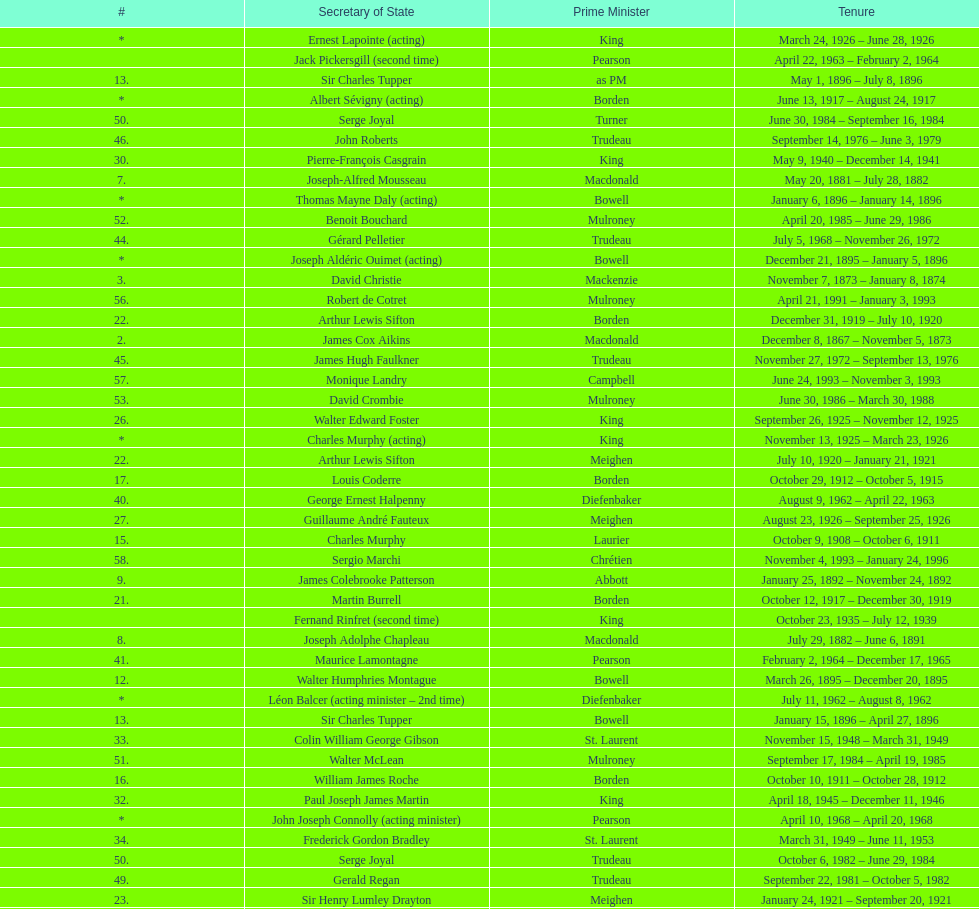Was macdonald prime minister before or after bowell? Before. 